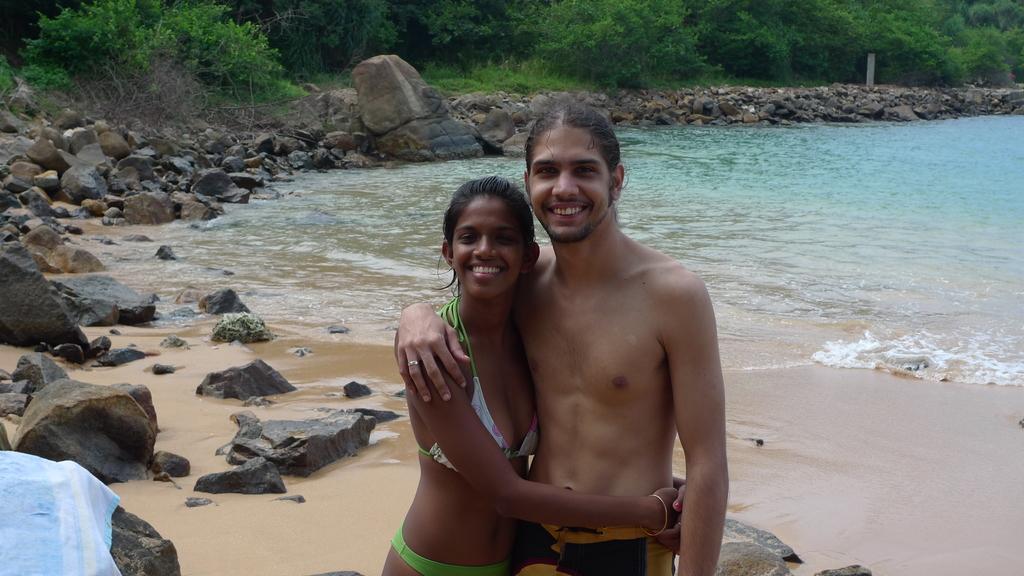Describe this image in one or two sentences. In this picture I can see there is a man and a woman standing, the man is wearing a trouser and there is a river on to right and there are few rocks, stones and sand on the floor and there is a towel placed into left and there are grass, plants and trees. 